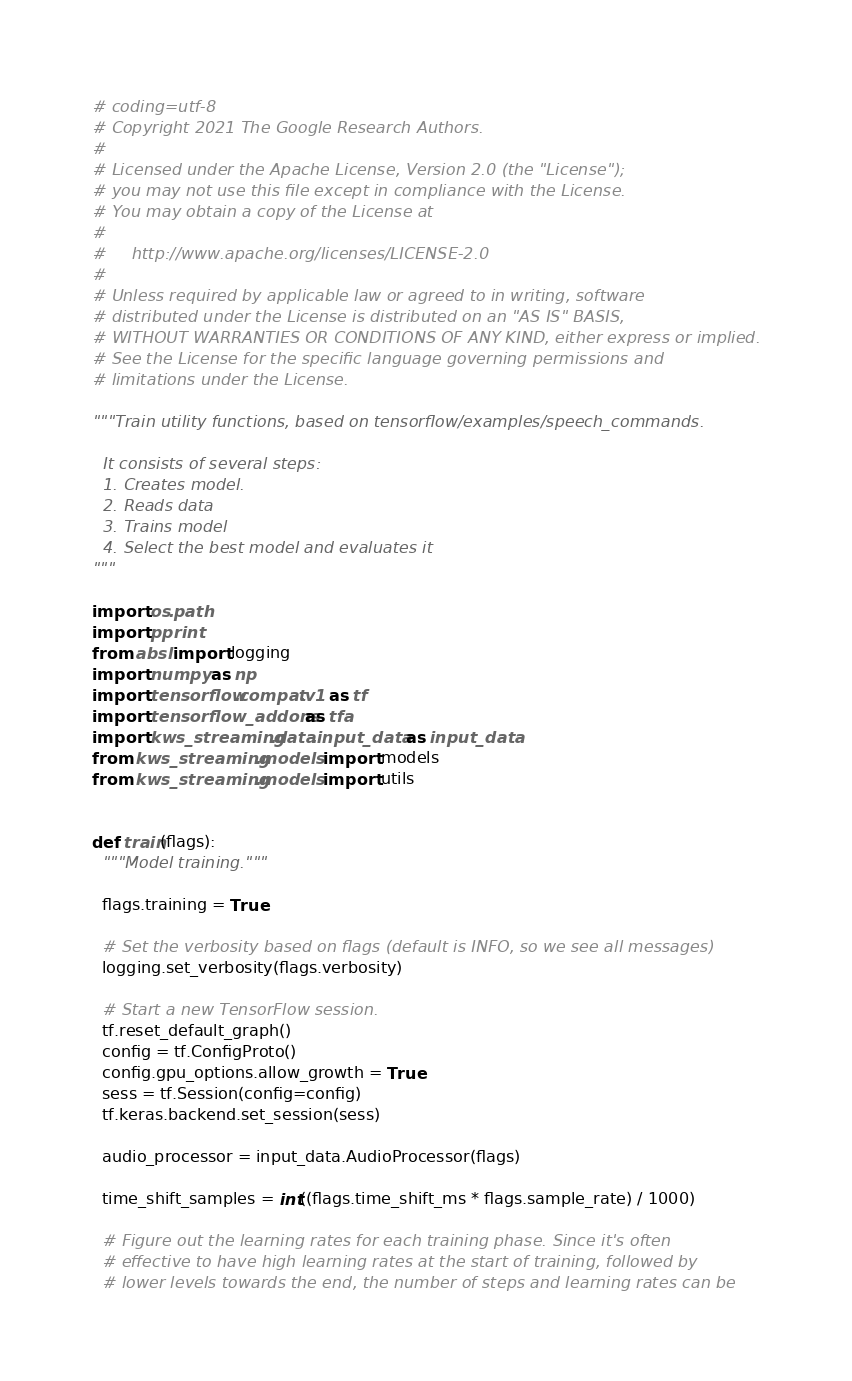<code> <loc_0><loc_0><loc_500><loc_500><_Python_># coding=utf-8
# Copyright 2021 The Google Research Authors.
#
# Licensed under the Apache License, Version 2.0 (the "License");
# you may not use this file except in compliance with the License.
# You may obtain a copy of the License at
#
#     http://www.apache.org/licenses/LICENSE-2.0
#
# Unless required by applicable law or agreed to in writing, software
# distributed under the License is distributed on an "AS IS" BASIS,
# WITHOUT WARRANTIES OR CONDITIONS OF ANY KIND, either express or implied.
# See the License for the specific language governing permissions and
# limitations under the License.

"""Train utility functions, based on tensorflow/examples/speech_commands.

  It consists of several steps:
  1. Creates model.
  2. Reads data
  3. Trains model
  4. Select the best model and evaluates it
"""

import os.path
import pprint
from absl import logging
import numpy as np
import tensorflow.compat.v1 as tf
import tensorflow_addons as tfa
import kws_streaming.data.input_data as input_data
from kws_streaming.models import models
from kws_streaming.models import utils


def train(flags):
  """Model training."""

  flags.training = True

  # Set the verbosity based on flags (default is INFO, so we see all messages)
  logging.set_verbosity(flags.verbosity)

  # Start a new TensorFlow session.
  tf.reset_default_graph()
  config = tf.ConfigProto()
  config.gpu_options.allow_growth = True
  sess = tf.Session(config=config)
  tf.keras.backend.set_session(sess)

  audio_processor = input_data.AudioProcessor(flags)

  time_shift_samples = int((flags.time_shift_ms * flags.sample_rate) / 1000)

  # Figure out the learning rates for each training phase. Since it's often
  # effective to have high learning rates at the start of training, followed by
  # lower levels towards the end, the number of steps and learning rates can be</code> 